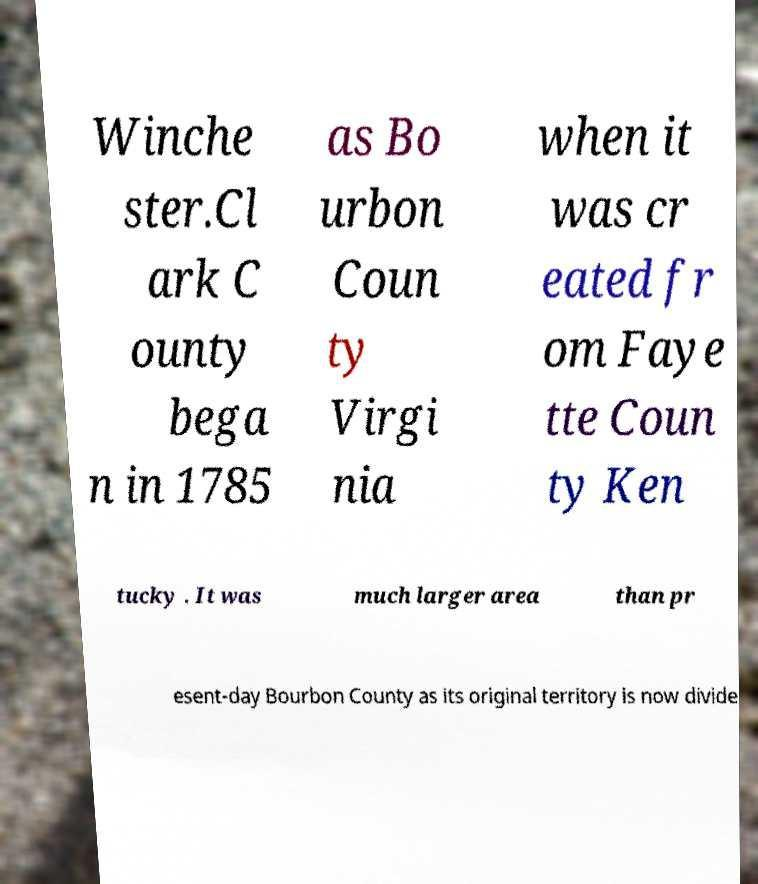For documentation purposes, I need the text within this image transcribed. Could you provide that? Winche ster.Cl ark C ounty bega n in 1785 as Bo urbon Coun ty Virgi nia when it was cr eated fr om Faye tte Coun ty Ken tucky . It was much larger area than pr esent-day Bourbon County as its original territory is now divide 